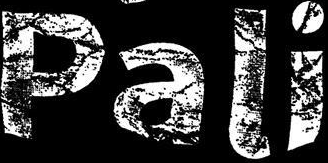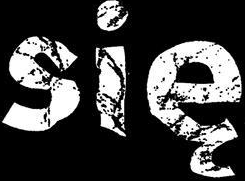What text is displayed in these images sequentially, separated by a semicolon? Pali; się 